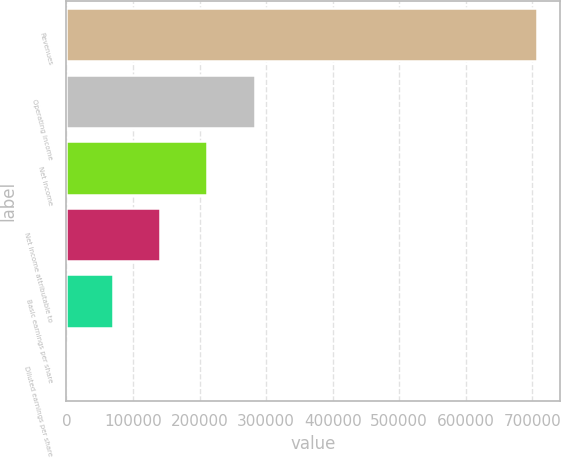Convert chart. <chart><loc_0><loc_0><loc_500><loc_500><bar_chart><fcel>Revenues<fcel>Operating income<fcel>Net income<fcel>Net income attributable to<fcel>Basic earnings per share<fcel>Diluted earnings per share<nl><fcel>706549<fcel>282620<fcel>211965<fcel>141310<fcel>70655.3<fcel>0.49<nl></chart> 